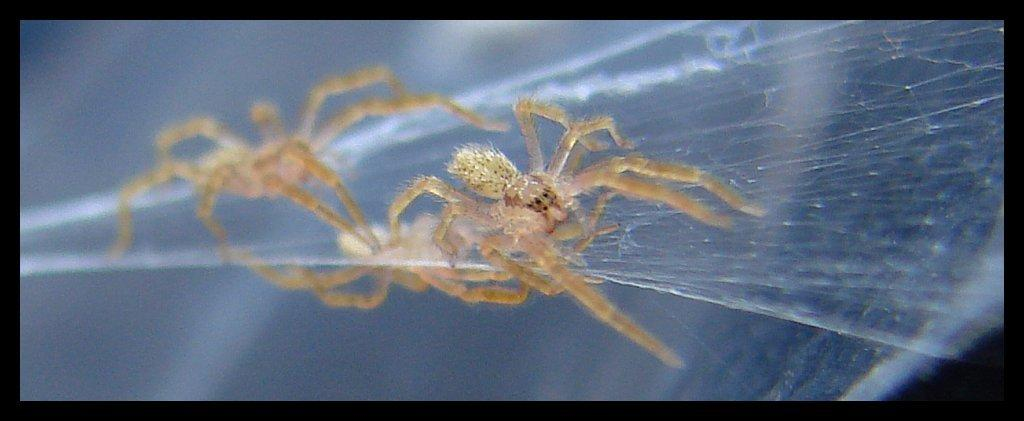What is the main subject of the image? The main subject of the image is a spider. What is the spider associated with in the image? There is a spider web in the image. What type of decision does the spider make in the image? There is no indication in the image that the spider is making any decisions. What is the texture of the spider's tail in the image? Spiders do not have tails, so there is no tail to describe the texture of in the image. 